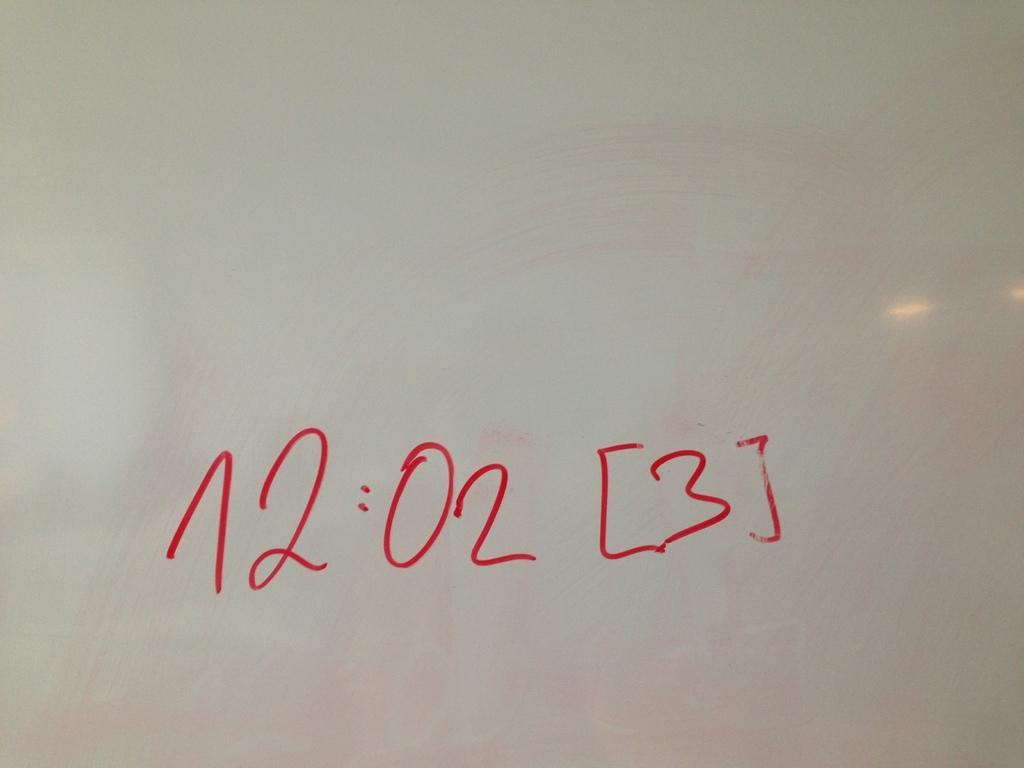<image>
Share a concise interpretation of the image provided. a white background with the time 12"02 written in red. 